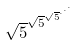<formula> <loc_0><loc_0><loc_500><loc_500>\sqrt { 5 } ^ { \sqrt { 5 } ^ { \sqrt { 5 } ^ { \cdot ^ { \cdot ^ { \cdot } } } } }</formula> 